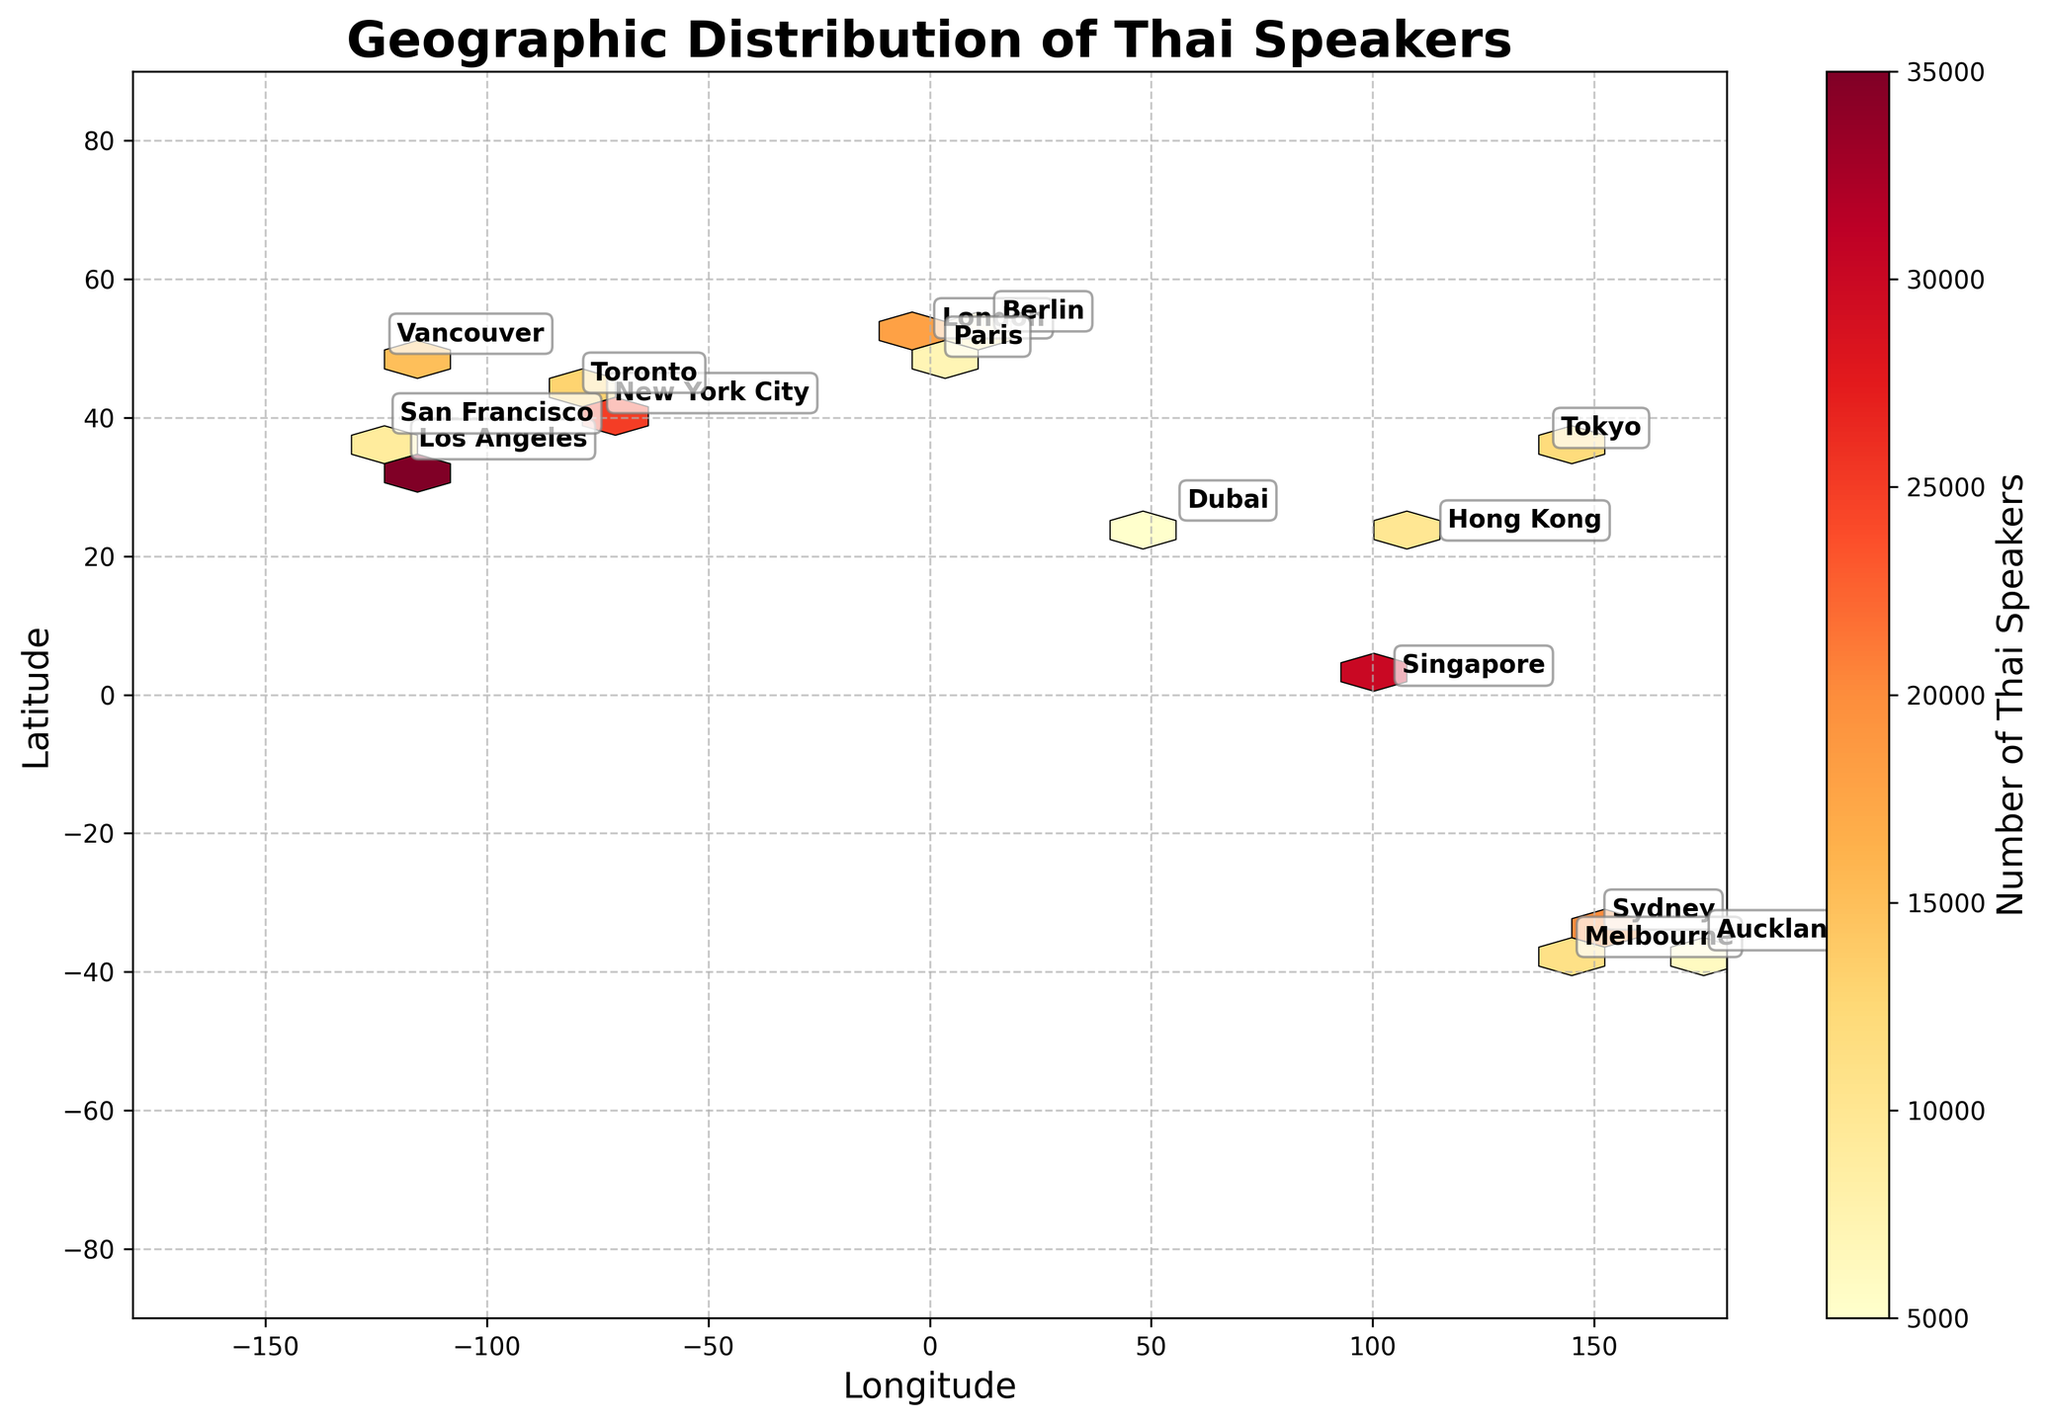What's the title of the figure? The title is positioned at the top of the plot and is usually in a larger, bold font to stand out.
Answer: Geographic Distribution of Thai Speakers What are the X and Y axes labeled as? The labels of the axes provide information about what is being measured and are typically found next to or below the axis lines.
Answer: Longitude for X, Latitude for Y Which city has the lowest number of Thai speakers? To find this, look for the city with the smallest hexbin coloring or the lowest number annotated near it.
Answer: Dubai Which city has the highest number of Thai speakers? Identify the city with the most intense color in the hexbin, corresponding to the highest count, or the largest annotated number.
Answer: Los Angeles How does the number of Thai speakers in Sydney compare to that in Melbourne? Locate both cities on the map, observe their respective colors in the hexbin, and compare the annotated numbers next to them.
Answer: Sydney has 20,000 speakers, while Melbourne has 11,000 speakers. Sydney has more What is the combined number of Thai speakers in all of the listed Canadian cities? Find and sum the numbers of Thai speakers in the Canadian cities listed (Toronto and Vancouver).
Answer: Vancouver: 15,000, Toronto: 13,000; Total = 28,000 Which continent has the most cities listed with Thai speakers? Identify the annotations on the map and count the cities by continent.
Answer: North America How does the count of Thai speakers in New York City compare to Tokyo? Compare the annotated numbers next to each city on the map.
Answer: New York City: 25,000, Tokyo: 12,000; New York City has more Which country has the most cities listed with Thai speakers? Determine the number of cities for each country by identifying annotations on the map.
Answer: USA What is the geographical spread (in latitude) between the northernmost and southernmost cities listed? Identify the cities with the highest and lowest latitudes and calculate the difference.
Answer: Berlin (52.5200) to Melbourne (-37.8136); Spread = 90.3336 degrees 